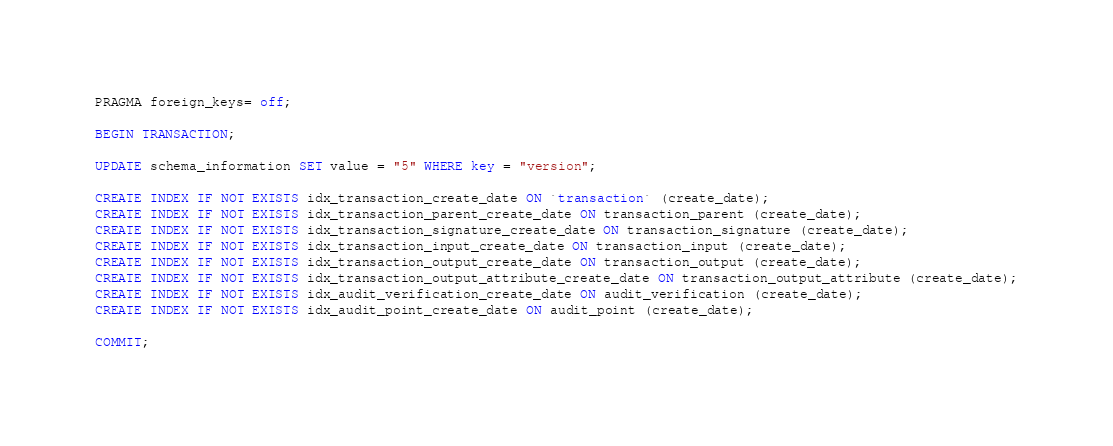<code> <loc_0><loc_0><loc_500><loc_500><_SQL_>PRAGMA foreign_keys= off;

BEGIN TRANSACTION;

UPDATE schema_information SET value = "5" WHERE key = "version";

CREATE INDEX IF NOT EXISTS idx_transaction_create_date ON `transaction` (create_date);
CREATE INDEX IF NOT EXISTS idx_transaction_parent_create_date ON transaction_parent (create_date);
CREATE INDEX IF NOT EXISTS idx_transaction_signature_create_date ON transaction_signature (create_date);
CREATE INDEX IF NOT EXISTS idx_transaction_input_create_date ON transaction_input (create_date);
CREATE INDEX IF NOT EXISTS idx_transaction_output_create_date ON transaction_output (create_date);
CREATE INDEX IF NOT EXISTS idx_transaction_output_attribute_create_date ON transaction_output_attribute (create_date);
CREATE INDEX IF NOT EXISTS idx_audit_verification_create_date ON audit_verification (create_date);
CREATE INDEX IF NOT EXISTS idx_audit_point_create_date ON audit_point (create_date);

COMMIT;
</code> 